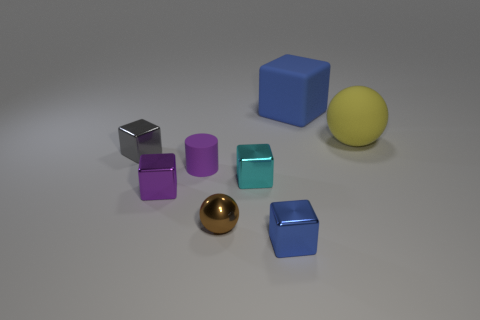Add 2 blue metallic blocks. How many objects exist? 10 Subtract all balls. How many objects are left? 6 Add 6 big matte spheres. How many big matte spheres exist? 7 Subtract 0 red cylinders. How many objects are left? 8 Subtract all shiny blocks. Subtract all large matte things. How many objects are left? 2 Add 4 metallic balls. How many metallic balls are left? 5 